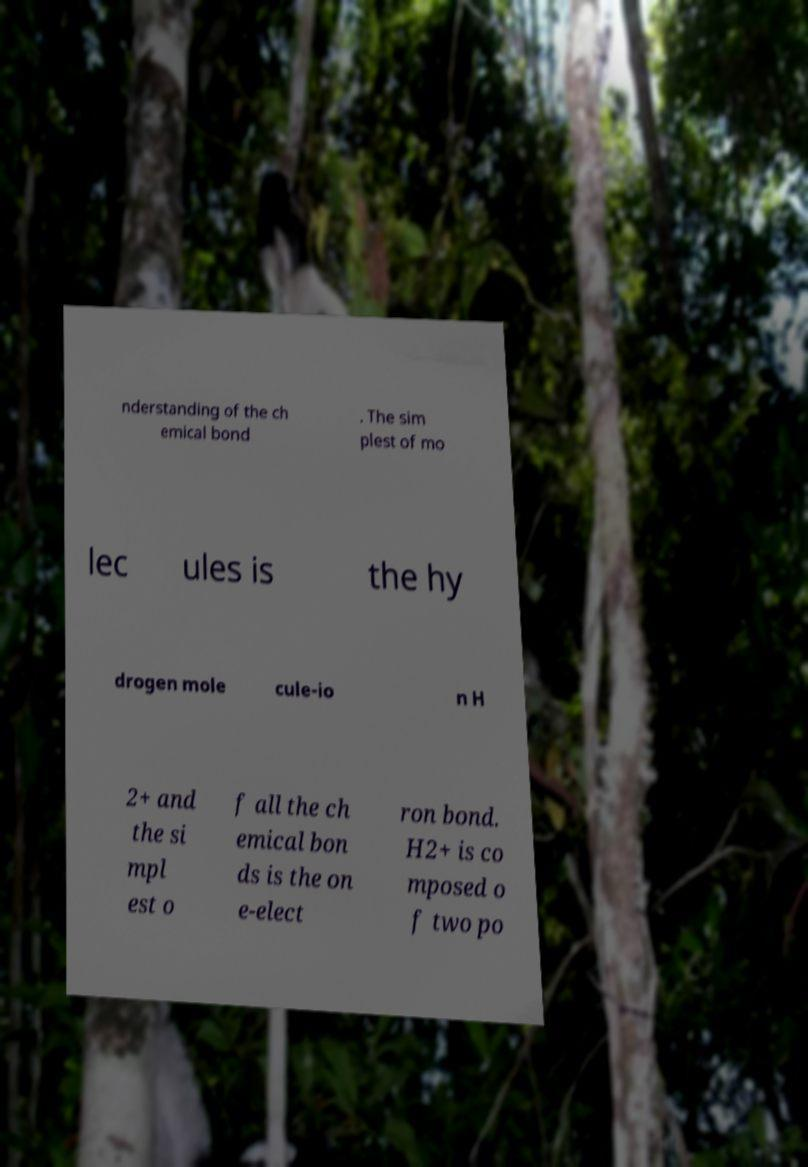What messages or text are displayed in this image? I need them in a readable, typed format. nderstanding of the ch emical bond . The sim plest of mo lec ules is the hy drogen mole cule-io n H 2+ and the si mpl est o f all the ch emical bon ds is the on e-elect ron bond. H2+ is co mposed o f two po 